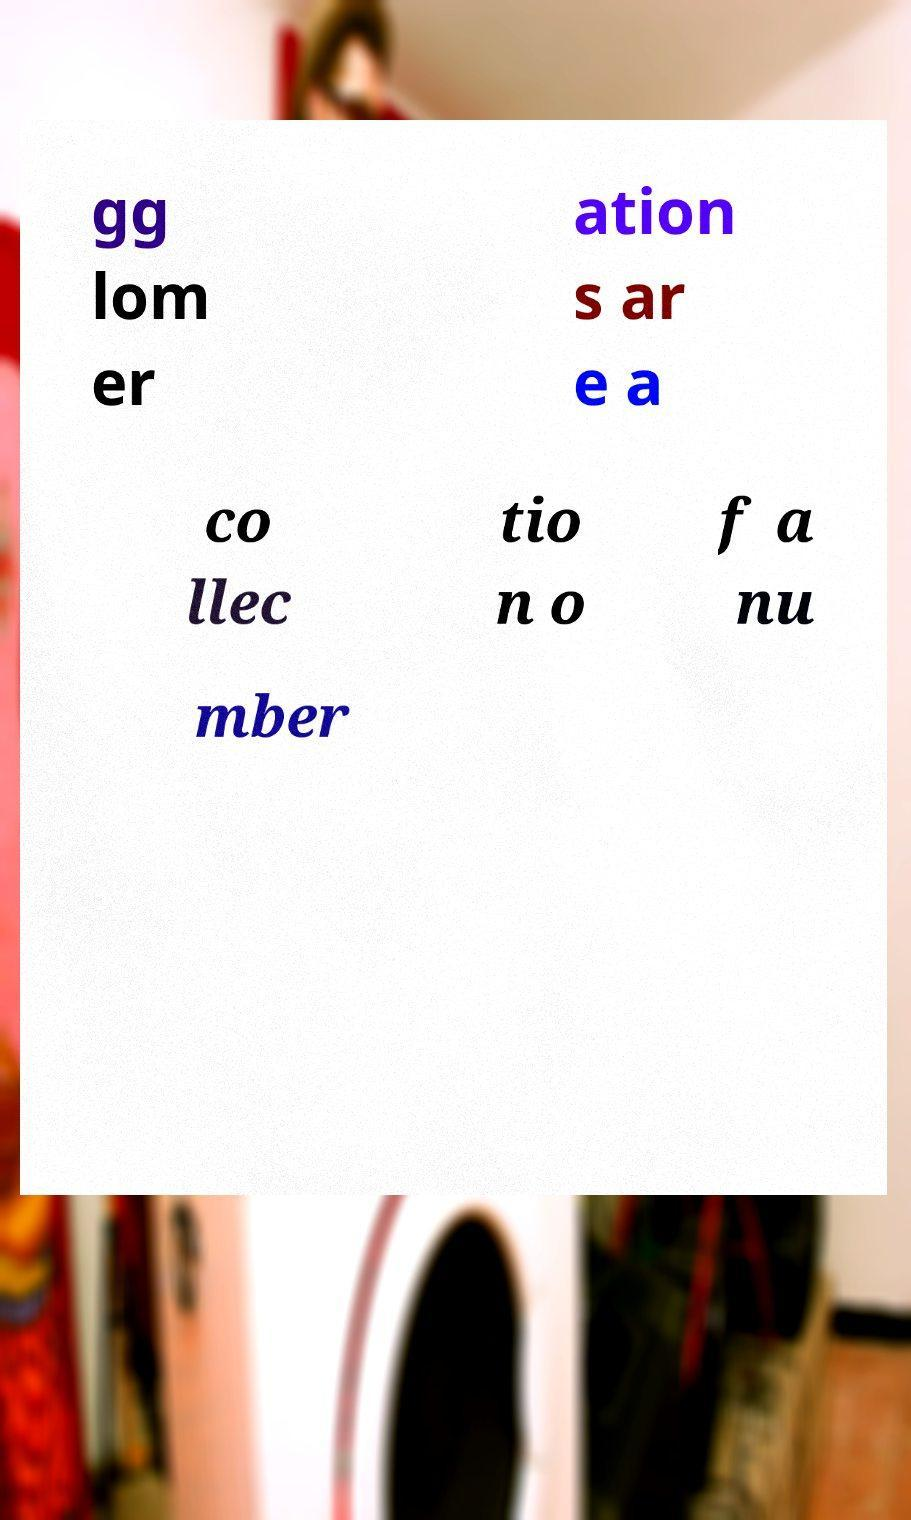For documentation purposes, I need the text within this image transcribed. Could you provide that? gg lom er ation s ar e a co llec tio n o f a nu mber 